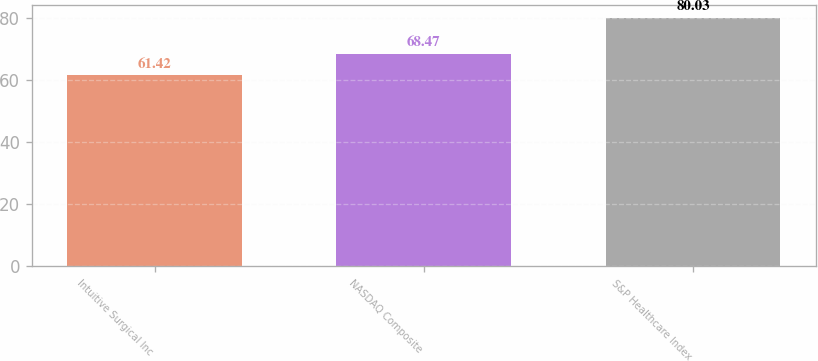Convert chart. <chart><loc_0><loc_0><loc_500><loc_500><bar_chart><fcel>Intuitive Surgical Inc<fcel>NASDAQ Composite<fcel>S&P Healthcare Index<nl><fcel>61.42<fcel>68.47<fcel>80.03<nl></chart> 